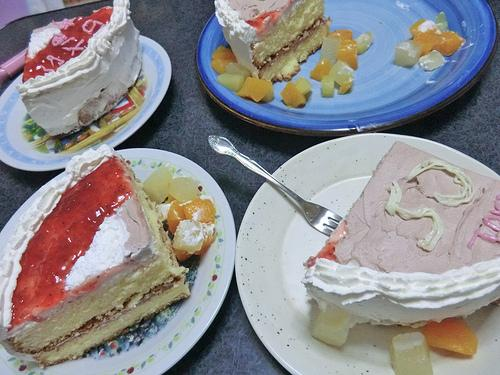Describe the placement of forks in the image. Forks can be found on the edge of white and blue ceramic plates, with handles positioned towards the plates' center. What is the general theme of the food presentation in the image? The image portrays a dessert theme featuring cake slices, fruit pieces, and coordinating tableware, like ceramic plates and forks. What are some unique attributes of the cakes in the image? Some cakes have two layers, white frosting around the sides, strawberry glaze on top, and numbers or writing on the frosting. How are the cakes decorated in the image? Cakes are decorated with white icing, pink frosting, strawberry glaze, red berry sauce, and writing, creating an appealing presentation. Describe the type of fruit accompanying some of the cake slices. There are pieces of diced peach, as well as a side of canned fruit accompanying some of the cake slices. Provide a description of the entire image scene. The image showcases a variety of cakes on colorful plates, served with pieces of fruit and forks, all set upon a table. Provide a brief overview of the objects displayed in the image. The image displays various desserts, such as cake slices with white and pink icing, on different colored ceramic plates, along with fruit pieces and forks. Elaborate on the different cake slices available in the image. The image features cake slices with white icing, pink frosting, red berry sauce, and strawberry glaze, some served with canned fruit. List the objects on blue-colored plates. Objects on blue plates include fruit pieces, chunks of fruit, and a dessert with two layers. Mention the colors and types of plates in the image. There are round white, blue, and flowered ceramic plates, as well as a plate with a blue border. 